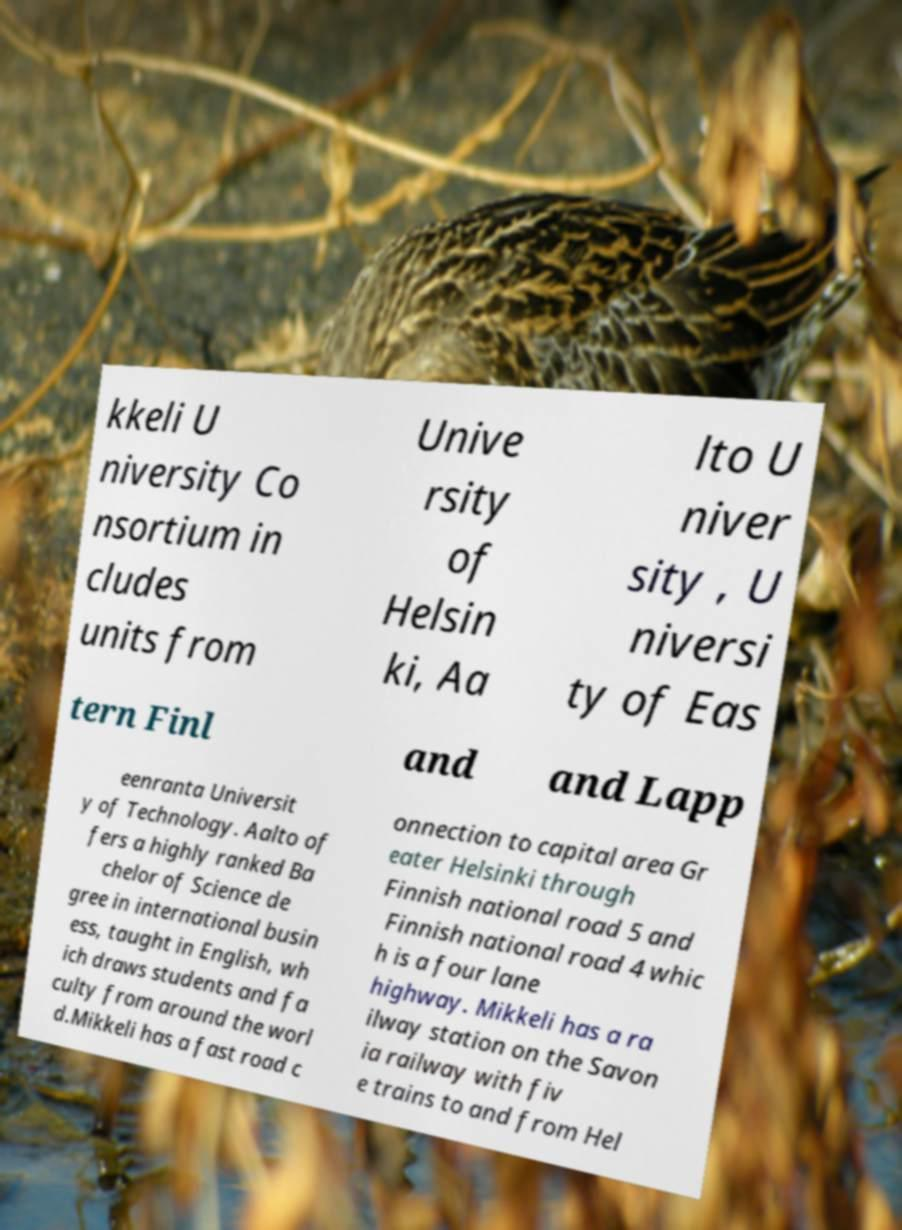Can you read and provide the text displayed in the image?This photo seems to have some interesting text. Can you extract and type it out for me? kkeli U niversity Co nsortium in cludes units from Unive rsity of Helsin ki, Aa lto U niver sity , U niversi ty of Eas tern Finl and and Lapp eenranta Universit y of Technology. Aalto of fers a highly ranked Ba chelor of Science de gree in international busin ess, taught in English, wh ich draws students and fa culty from around the worl d.Mikkeli has a fast road c onnection to capital area Gr eater Helsinki through Finnish national road 5 and Finnish national road 4 whic h is a four lane highway. Mikkeli has a ra ilway station on the Savon ia railway with fiv e trains to and from Hel 